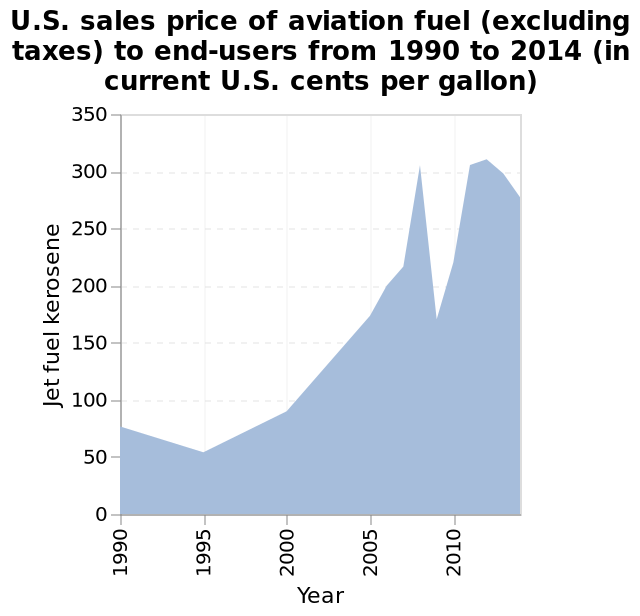<image>
please enumerates aspects of the construction of the chart This area graph is titled U.S. sales price of aviation fuel (excluding taxes) to end-users from 1990 to 2014 (in current U.S. cents per gallon). The x-axis measures Year along linear scale with a minimum of 1990 and a maximum of 2010 while the y-axis plots Jet fuel kerosene on linear scale with a minimum of 0 and a maximum of 350. How is the x-axis measured in the graph?  The x-axis is measured in years along a linear scale, with a minimum value of 1990 and a maximum value of 2010. Is the x-axis measured in months along a non-linear scale, with a minimum value of 2050 and a maximum value of 2015? No. The x-axis is measured in years along a linear scale, with a minimum value of 1990 and a maximum value of 2010. 